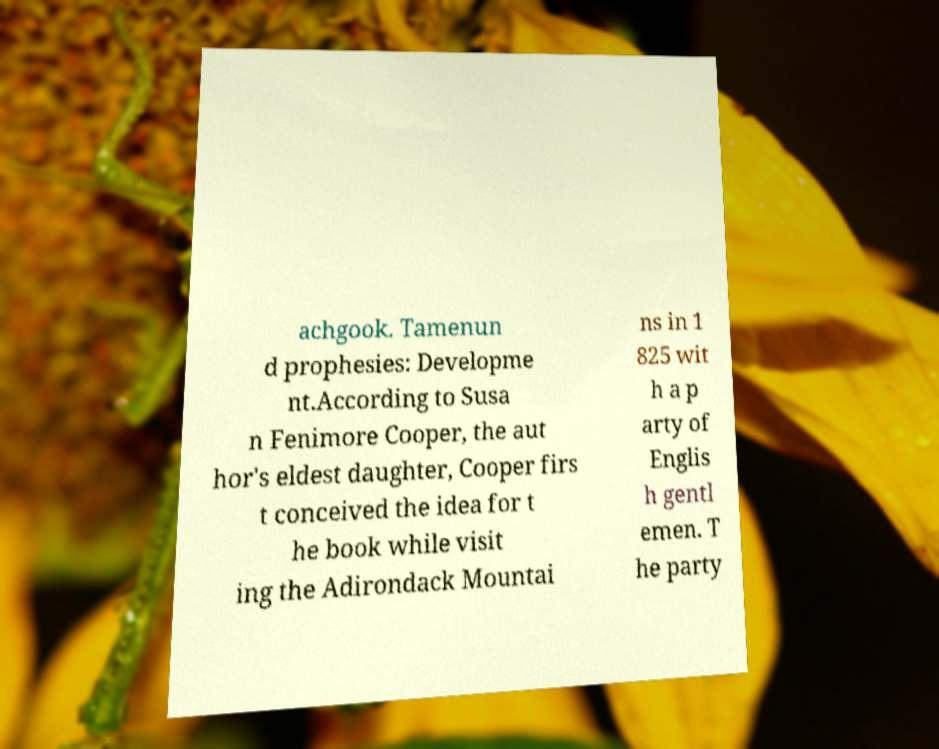Please read and relay the text visible in this image. What does it say? achgook. Tamenun d prophesies: Developme nt.According to Susa n Fenimore Cooper, the aut hor's eldest daughter, Cooper firs t conceived the idea for t he book while visit ing the Adirondack Mountai ns in 1 825 wit h a p arty of Englis h gentl emen. T he party 